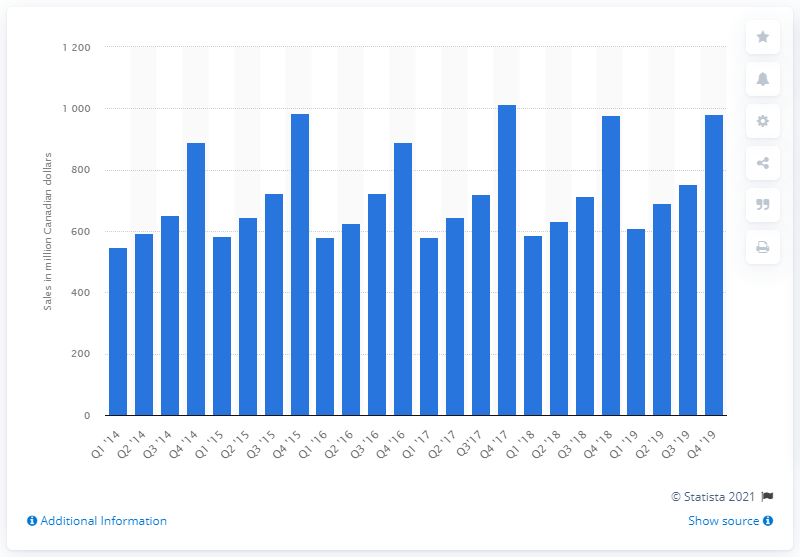Highlight a few significant elements in this photo. In the fourth quarter of 2019, the retail sales of tableware, kitchenware, cookware, and bakeware in Canada totaled 981.47 million Canadian dollars. 